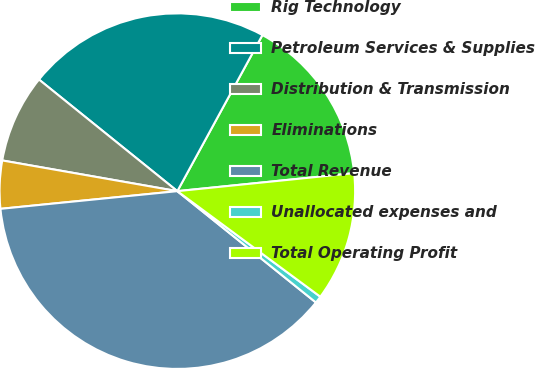<chart> <loc_0><loc_0><loc_500><loc_500><pie_chart><fcel>Rig Technology<fcel>Petroleum Services & Supplies<fcel>Distribution & Transmission<fcel>Eliminations<fcel>Total Revenue<fcel>Unallocated expenses and<fcel>Total Operating Profit<nl><fcel>15.44%<fcel>22.14%<fcel>8.04%<fcel>4.35%<fcel>37.64%<fcel>0.65%<fcel>11.74%<nl></chart> 